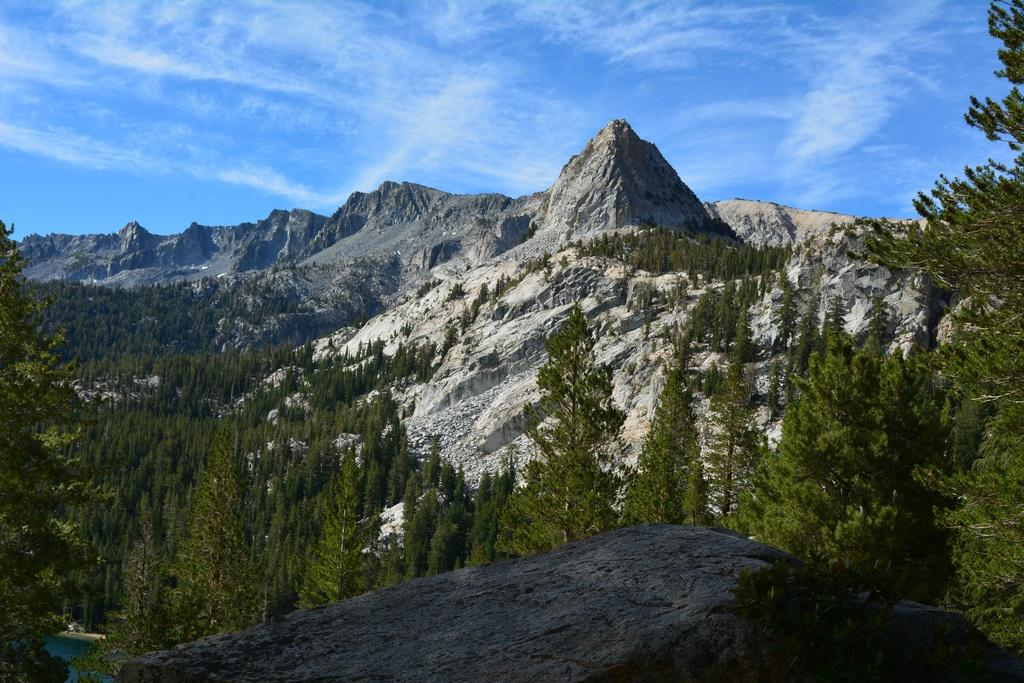What type of vegetation can be seen in the image? There are trees in the image. What natural features are visible in the background of the image? There are mountains in the background of the image. What is visible at the top of the image? The sky is visible at the top of the image. Can you see a plough being used in the image? There is no plough present in the image. What type of stone can be seen in the image? There is no stone visible in the image. 